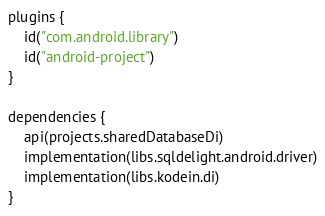Convert code to text. <code><loc_0><loc_0><loc_500><loc_500><_Kotlin_>plugins {
    id("com.android.library")
    id("android-project")
}

dependencies {
    api(projects.sharedDatabaseDi)
    implementation(libs.sqldelight.android.driver)
    implementation(libs.kodein.di)
}
</code> 